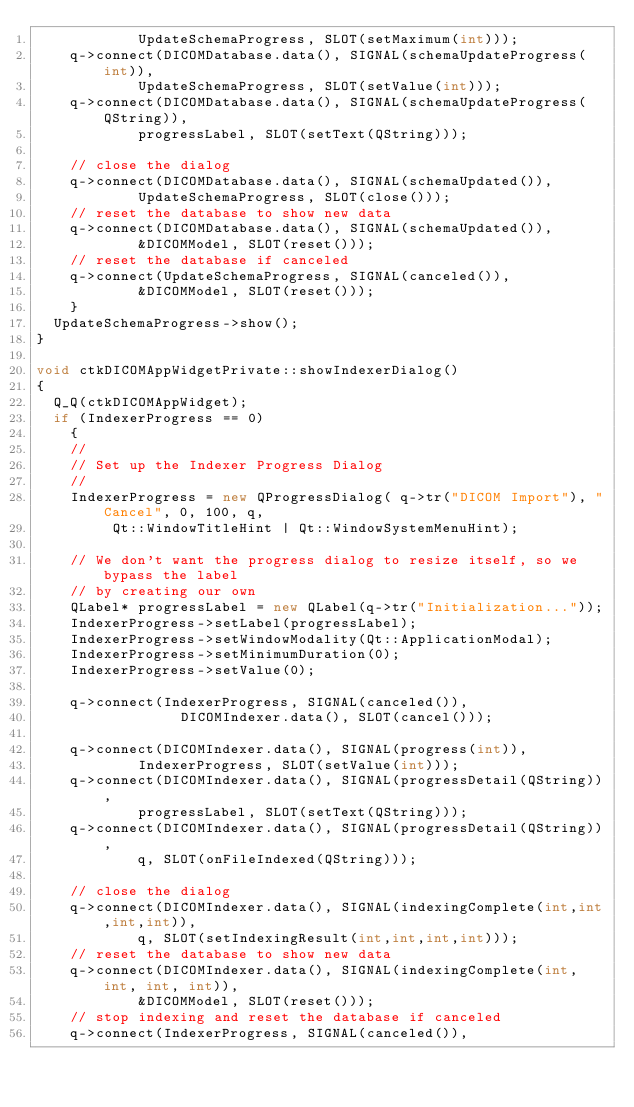Convert code to text. <code><loc_0><loc_0><loc_500><loc_500><_C++_>            UpdateSchemaProgress, SLOT(setMaximum(int)));
    q->connect(DICOMDatabase.data(), SIGNAL(schemaUpdateProgress(int)),
            UpdateSchemaProgress, SLOT(setValue(int)));
    q->connect(DICOMDatabase.data(), SIGNAL(schemaUpdateProgress(QString)),
            progressLabel, SLOT(setText(QString)));

    // close the dialog
    q->connect(DICOMDatabase.data(), SIGNAL(schemaUpdated()),
            UpdateSchemaProgress, SLOT(close()));
    // reset the database to show new data
    q->connect(DICOMDatabase.data(), SIGNAL(schemaUpdated()),
            &DICOMModel, SLOT(reset()));
    // reset the database if canceled
    q->connect(UpdateSchemaProgress, SIGNAL(canceled()), 
            &DICOMModel, SLOT(reset()));
    }
  UpdateSchemaProgress->show();
}

void ctkDICOMAppWidgetPrivate::showIndexerDialog()
{
  Q_Q(ctkDICOMAppWidget);
  if (IndexerProgress == 0)
    {
    //
    // Set up the Indexer Progress Dialog
    //
    IndexerProgress = new QProgressDialog( q->tr("DICOM Import"), "Cancel", 0, 100, q,
         Qt::WindowTitleHint | Qt::WindowSystemMenuHint);

    // We don't want the progress dialog to resize itself, so we bypass the label
    // by creating our own
    QLabel* progressLabel = new QLabel(q->tr("Initialization..."));
    IndexerProgress->setLabel(progressLabel);
    IndexerProgress->setWindowModality(Qt::ApplicationModal);
    IndexerProgress->setMinimumDuration(0);
    IndexerProgress->setValue(0);

    q->connect(IndexerProgress, SIGNAL(canceled()), 
                 DICOMIndexer.data(), SLOT(cancel()));

    q->connect(DICOMIndexer.data(), SIGNAL(progress(int)),
            IndexerProgress, SLOT(setValue(int)));
    q->connect(DICOMIndexer.data(), SIGNAL(progressDetail(QString)),
            progressLabel, SLOT(setText(QString)));
    q->connect(DICOMIndexer.data(), SIGNAL(progressDetail(QString)),
            q, SLOT(onFileIndexed(QString)));

    // close the dialog
    q->connect(DICOMIndexer.data(), SIGNAL(indexingComplete(int,int,int,int)),
            q, SLOT(setIndexingResult(int,int,int,int)));
    // reset the database to show new data
    q->connect(DICOMIndexer.data(), SIGNAL(indexingComplete(int, int, int, int)),
            &DICOMModel, SLOT(reset()));
    // stop indexing and reset the database if canceled
    q->connect(IndexerProgress, SIGNAL(canceled()), </code> 